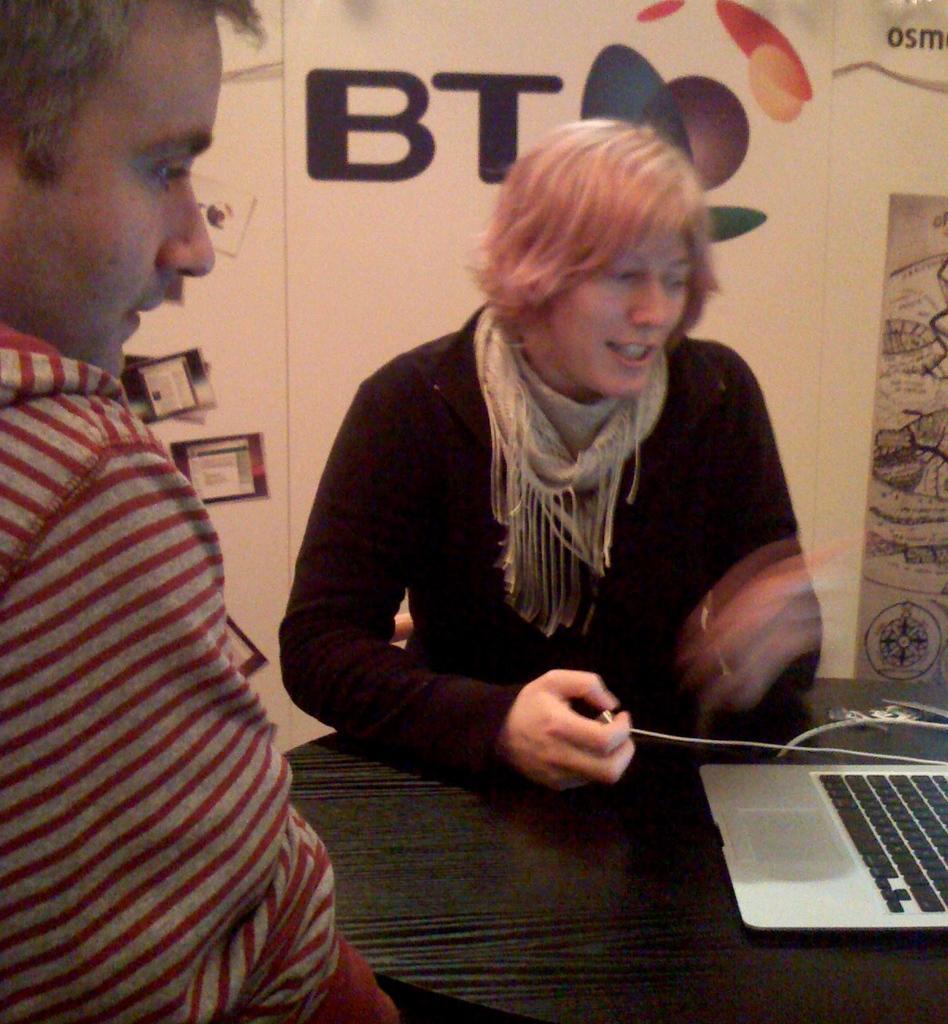Can you describe this image briefly? In this image there is a woman and a man sitting on chairs, in middle there is a table on that table there is a laptop, in the background there is a wall, on that wall there is some text. 